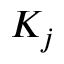Convert formula to latex. <formula><loc_0><loc_0><loc_500><loc_500>K _ { j }</formula> 